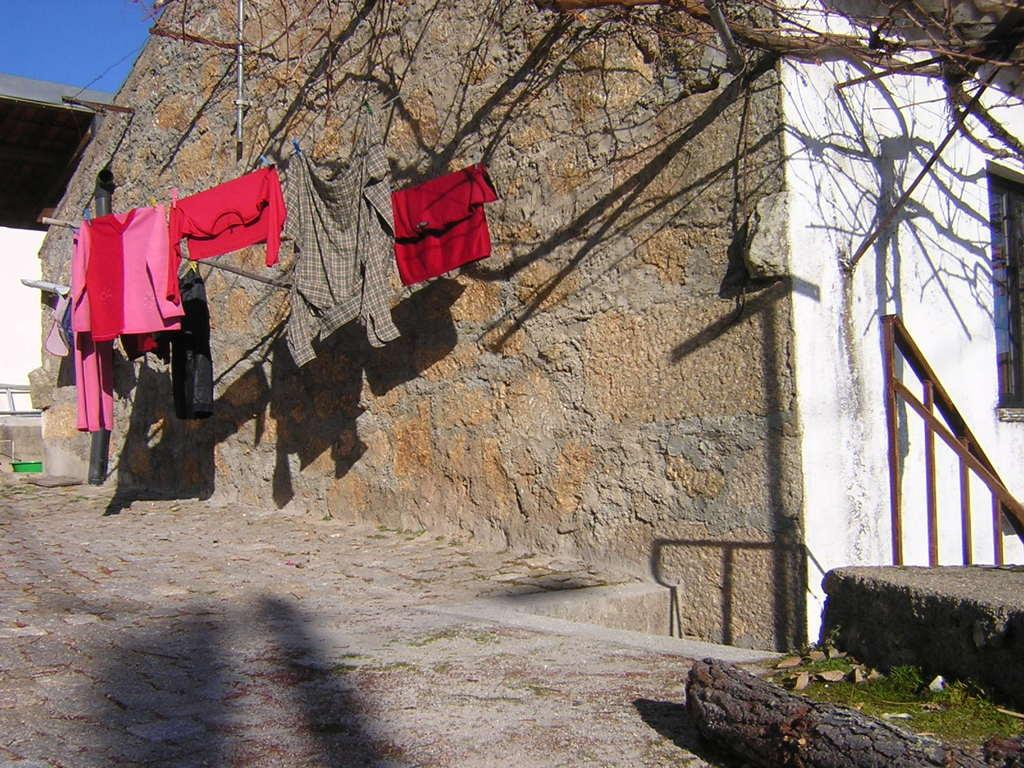What is hanging on the rope in the image? There are clothes hanging on a rope in the image. Where is the rope tied to in the image? The rope is tied to the wall of a home in the image. What can be seen on the left side of the image? There is a staircase on the left side of the image. What is visible at the top of the image? The sky is visible at the top of the image. What type of game is being played on the staircase in the image? There is no game being played on the staircase in the image. What color is the paint on the wall where the rope is tied to? The provided facts do not mention the color of the paint on the wall, so we cannot determine that information from the image. 